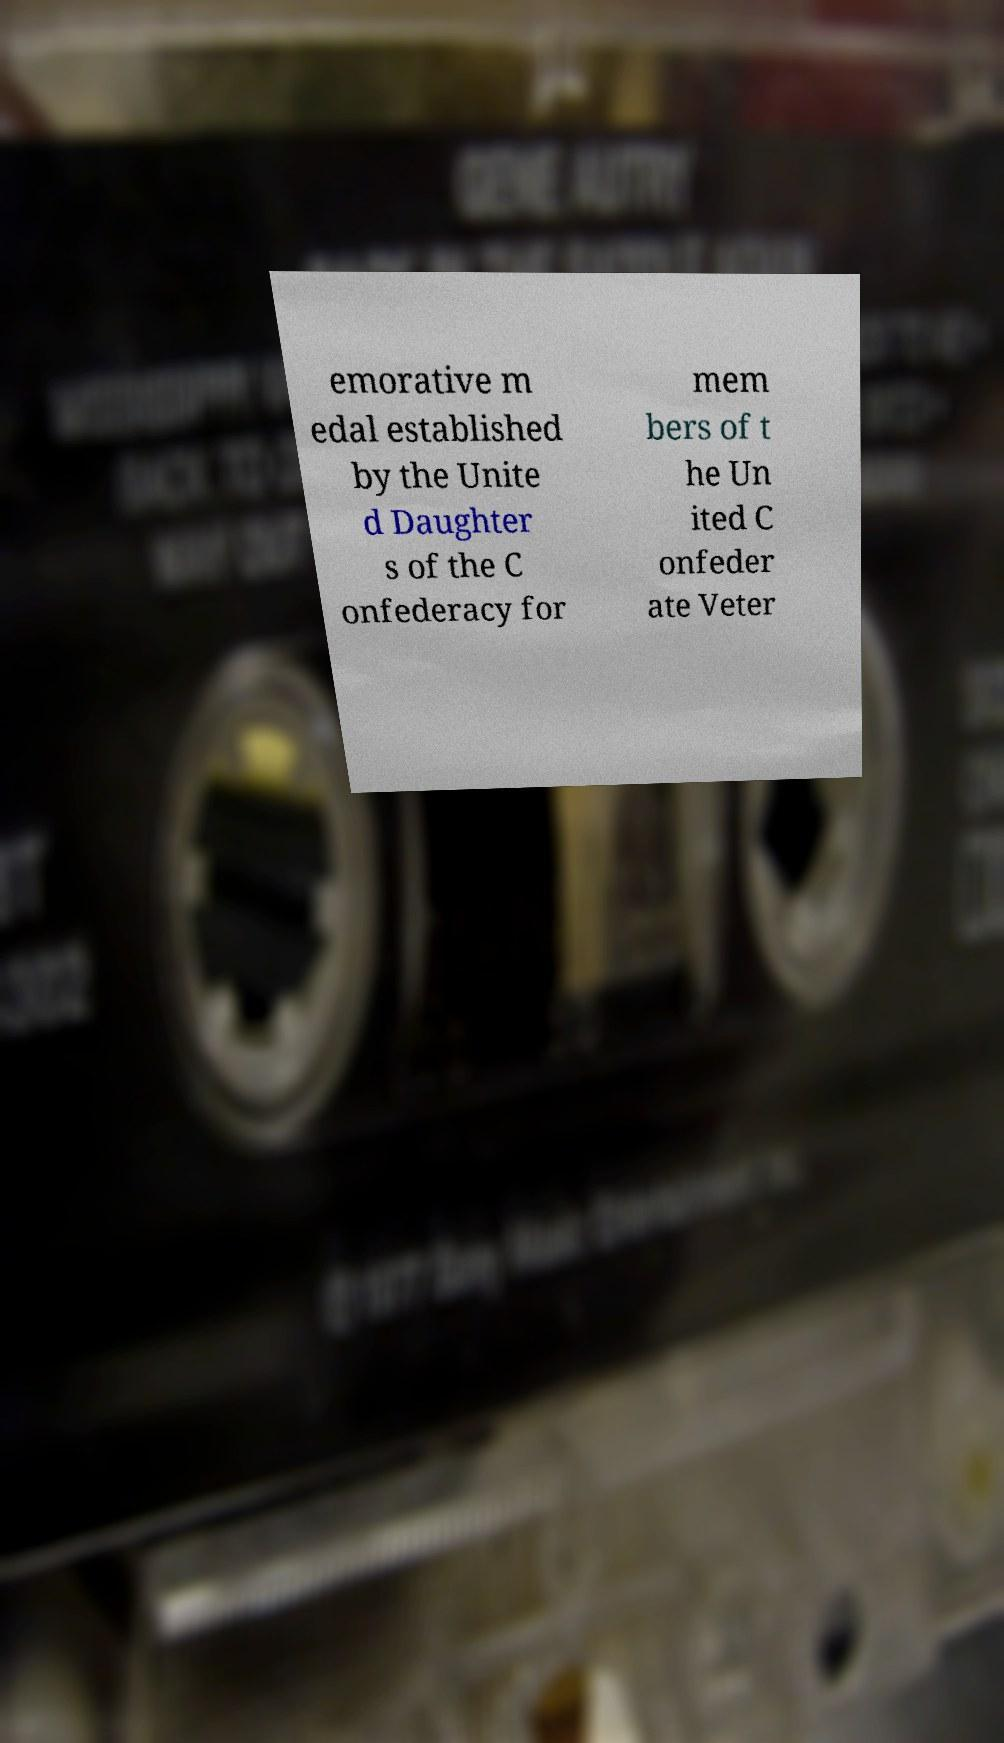I need the written content from this picture converted into text. Can you do that? emorative m edal established by the Unite d Daughter s of the C onfederacy for mem bers of t he Un ited C onfeder ate Veter 